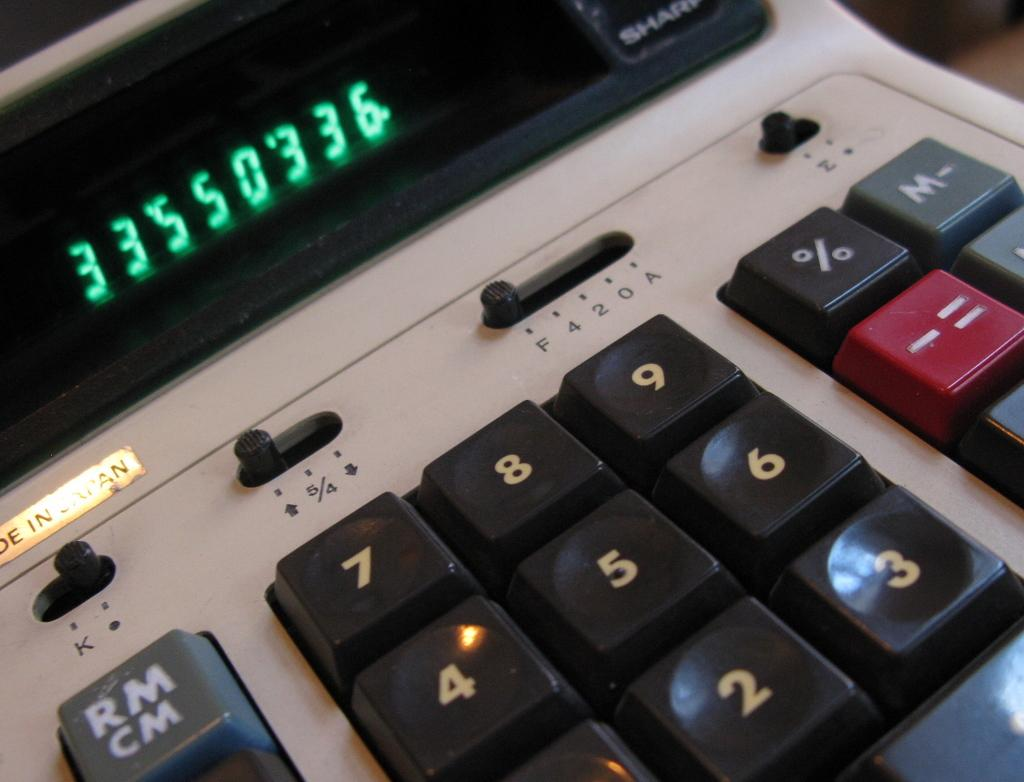<image>
Present a compact description of the photo's key features. A calculator with the number 33550336 on the screen. 